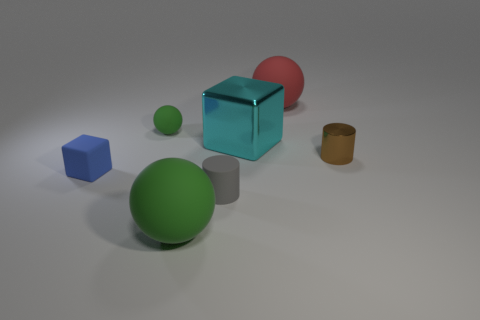There is a large cyan metallic thing that is on the right side of the blue rubber cube; what shape is it?
Keep it short and to the point. Cube. What number of tiny rubber cubes are there?
Ensure brevity in your answer.  1. Does the gray object have the same material as the red sphere?
Your response must be concise. Yes. Is the number of large rubber objects behind the large cube greater than the number of big red things?
Offer a terse response. No. What number of things are tiny rubber cubes or metal things that are behind the brown cylinder?
Your answer should be compact. 2. Is the number of small matte objects that are on the left side of the blue cube greater than the number of objects in front of the gray cylinder?
Provide a succinct answer. No. What material is the blue object that is behind the large rubber ball left of the small cylinder to the left of the small brown shiny object?
Provide a succinct answer. Rubber. There is a blue object that is made of the same material as the gray cylinder; what shape is it?
Your answer should be compact. Cube. There is a large green sphere that is in front of the small green object; is there a blue block in front of it?
Provide a succinct answer. No. What size is the blue thing?
Provide a succinct answer. Small. 